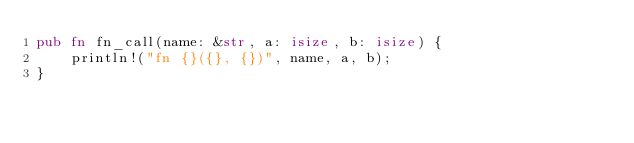Convert code to text. <code><loc_0><loc_0><loc_500><loc_500><_Rust_>pub fn fn_call(name: &str, a: isize, b: isize) {
	println!("fn {}({}, {})", name, a, b);
}
</code> 